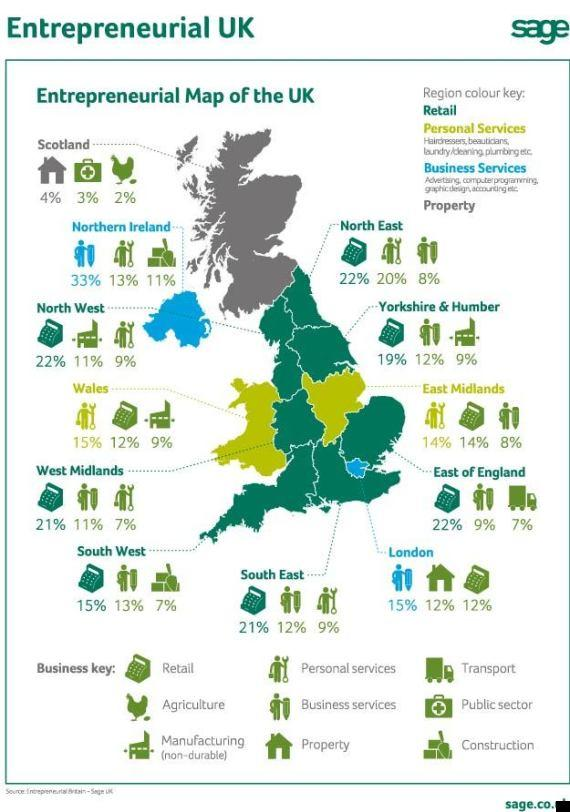List a handful of essential elements in this visual. In Scotland, only 2% of the population are agro entrepreneurs. In London, it is estimated that approximately 15% of the population are property entrepreneurs. In Wales, approximately 12% of the population are retail entrepreneurs. Entrepreneurship in business services is prevalent in Northern Ireland and London in the United Kingdom. Scotland is the only country within the United Kingdom that is home to agro entrepreneurs. 